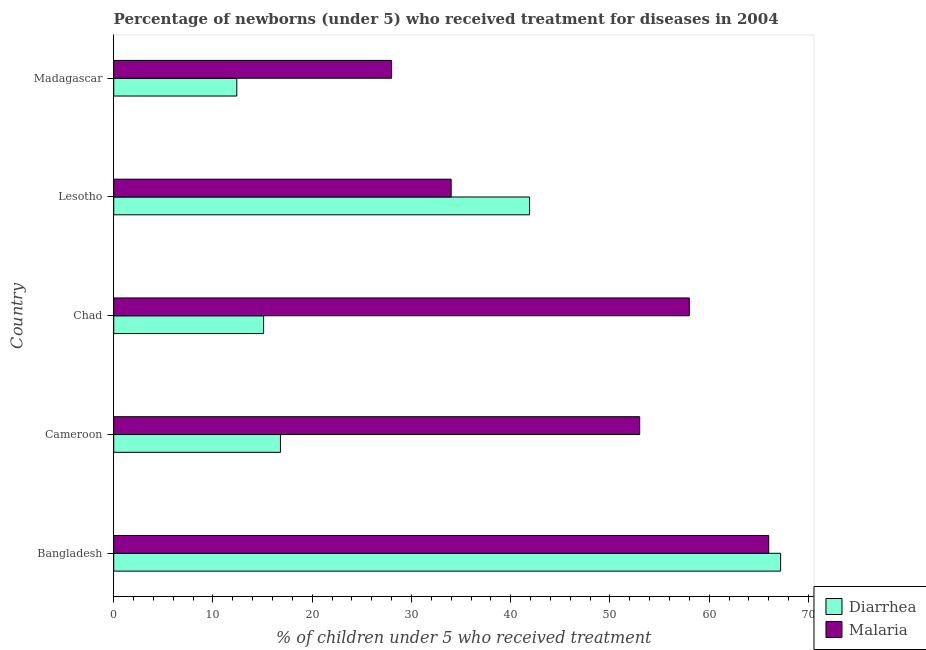How many different coloured bars are there?
Provide a short and direct response. 2. How many groups of bars are there?
Offer a very short reply. 5. How many bars are there on the 5th tick from the top?
Keep it short and to the point. 2. How many bars are there on the 1st tick from the bottom?
Offer a terse response. 2. What is the label of the 1st group of bars from the top?
Offer a terse response. Madagascar. What is the percentage of children who received treatment for malaria in Madagascar?
Make the answer very short. 28. Across all countries, what is the maximum percentage of children who received treatment for diarrhoea?
Ensure brevity in your answer.  67.2. Across all countries, what is the minimum percentage of children who received treatment for diarrhoea?
Provide a short and direct response. 12.4. In which country was the percentage of children who received treatment for malaria minimum?
Ensure brevity in your answer.  Madagascar. What is the total percentage of children who received treatment for diarrhoea in the graph?
Offer a terse response. 153.4. What is the difference between the percentage of children who received treatment for diarrhoea in Lesotho and that in Madagascar?
Your answer should be compact. 29.5. What is the difference between the percentage of children who received treatment for diarrhoea in Bangladesh and the percentage of children who received treatment for malaria in Madagascar?
Your answer should be compact. 39.2. What is the average percentage of children who received treatment for malaria per country?
Offer a very short reply. 47.8. What is the difference between the percentage of children who received treatment for diarrhoea and percentage of children who received treatment for malaria in Chad?
Your answer should be compact. -42.9. In how many countries, is the percentage of children who received treatment for malaria greater than 54 %?
Your answer should be compact. 2. What is the ratio of the percentage of children who received treatment for malaria in Bangladesh to that in Cameroon?
Give a very brief answer. 1.25. Is the percentage of children who received treatment for diarrhoea in Bangladesh less than that in Lesotho?
Your answer should be very brief. No. Is the difference between the percentage of children who received treatment for diarrhoea in Cameroon and Chad greater than the difference between the percentage of children who received treatment for malaria in Cameroon and Chad?
Your answer should be very brief. Yes. What is the difference between the highest and the second highest percentage of children who received treatment for malaria?
Make the answer very short. 8. What is the difference between the highest and the lowest percentage of children who received treatment for malaria?
Keep it short and to the point. 38. What does the 1st bar from the top in Bangladesh represents?
Offer a terse response. Malaria. What does the 1st bar from the bottom in Lesotho represents?
Provide a succinct answer. Diarrhea. Are the values on the major ticks of X-axis written in scientific E-notation?
Your answer should be very brief. No. Does the graph contain any zero values?
Your answer should be compact. No. How many legend labels are there?
Ensure brevity in your answer.  2. How are the legend labels stacked?
Provide a short and direct response. Vertical. What is the title of the graph?
Make the answer very short. Percentage of newborns (under 5) who received treatment for diseases in 2004. What is the label or title of the X-axis?
Offer a terse response. % of children under 5 who received treatment. What is the % of children under 5 who received treatment in Diarrhea in Bangladesh?
Make the answer very short. 67.2. What is the % of children under 5 who received treatment of Malaria in Bangladesh?
Make the answer very short. 66. What is the % of children under 5 who received treatment in Diarrhea in Cameroon?
Ensure brevity in your answer.  16.8. What is the % of children under 5 who received treatment of Malaria in Cameroon?
Give a very brief answer. 53. What is the % of children under 5 who received treatment in Diarrhea in Chad?
Provide a succinct answer. 15.1. What is the % of children under 5 who received treatment in Diarrhea in Lesotho?
Provide a succinct answer. 41.9. What is the % of children under 5 who received treatment of Malaria in Lesotho?
Offer a very short reply. 34. What is the % of children under 5 who received treatment of Malaria in Madagascar?
Your response must be concise. 28. Across all countries, what is the maximum % of children under 5 who received treatment in Diarrhea?
Keep it short and to the point. 67.2. Across all countries, what is the maximum % of children under 5 who received treatment of Malaria?
Keep it short and to the point. 66. Across all countries, what is the minimum % of children under 5 who received treatment of Diarrhea?
Ensure brevity in your answer.  12.4. What is the total % of children under 5 who received treatment of Diarrhea in the graph?
Provide a succinct answer. 153.4. What is the total % of children under 5 who received treatment in Malaria in the graph?
Make the answer very short. 239. What is the difference between the % of children under 5 who received treatment in Diarrhea in Bangladesh and that in Cameroon?
Provide a short and direct response. 50.4. What is the difference between the % of children under 5 who received treatment of Diarrhea in Bangladesh and that in Chad?
Offer a very short reply. 52.1. What is the difference between the % of children under 5 who received treatment of Malaria in Bangladesh and that in Chad?
Give a very brief answer. 8. What is the difference between the % of children under 5 who received treatment in Diarrhea in Bangladesh and that in Lesotho?
Your answer should be compact. 25.3. What is the difference between the % of children under 5 who received treatment of Diarrhea in Bangladesh and that in Madagascar?
Your answer should be compact. 54.8. What is the difference between the % of children under 5 who received treatment of Malaria in Bangladesh and that in Madagascar?
Provide a short and direct response. 38. What is the difference between the % of children under 5 who received treatment of Malaria in Cameroon and that in Chad?
Your answer should be compact. -5. What is the difference between the % of children under 5 who received treatment in Diarrhea in Cameroon and that in Lesotho?
Offer a very short reply. -25.1. What is the difference between the % of children under 5 who received treatment in Diarrhea in Chad and that in Lesotho?
Your answer should be compact. -26.8. What is the difference between the % of children under 5 who received treatment of Malaria in Chad and that in Lesotho?
Keep it short and to the point. 24. What is the difference between the % of children under 5 who received treatment in Diarrhea in Lesotho and that in Madagascar?
Keep it short and to the point. 29.5. What is the difference between the % of children under 5 who received treatment of Diarrhea in Bangladesh and the % of children under 5 who received treatment of Malaria in Cameroon?
Your response must be concise. 14.2. What is the difference between the % of children under 5 who received treatment of Diarrhea in Bangladesh and the % of children under 5 who received treatment of Malaria in Chad?
Offer a very short reply. 9.2. What is the difference between the % of children under 5 who received treatment in Diarrhea in Bangladesh and the % of children under 5 who received treatment in Malaria in Lesotho?
Your answer should be very brief. 33.2. What is the difference between the % of children under 5 who received treatment of Diarrhea in Bangladesh and the % of children under 5 who received treatment of Malaria in Madagascar?
Keep it short and to the point. 39.2. What is the difference between the % of children under 5 who received treatment of Diarrhea in Cameroon and the % of children under 5 who received treatment of Malaria in Chad?
Keep it short and to the point. -41.2. What is the difference between the % of children under 5 who received treatment in Diarrhea in Cameroon and the % of children under 5 who received treatment in Malaria in Lesotho?
Give a very brief answer. -17.2. What is the difference between the % of children under 5 who received treatment in Diarrhea in Cameroon and the % of children under 5 who received treatment in Malaria in Madagascar?
Your answer should be very brief. -11.2. What is the difference between the % of children under 5 who received treatment of Diarrhea in Chad and the % of children under 5 who received treatment of Malaria in Lesotho?
Make the answer very short. -18.9. What is the difference between the % of children under 5 who received treatment in Diarrhea in Lesotho and the % of children under 5 who received treatment in Malaria in Madagascar?
Your answer should be very brief. 13.9. What is the average % of children under 5 who received treatment of Diarrhea per country?
Your response must be concise. 30.68. What is the average % of children under 5 who received treatment of Malaria per country?
Keep it short and to the point. 47.8. What is the difference between the % of children under 5 who received treatment in Diarrhea and % of children under 5 who received treatment in Malaria in Cameroon?
Ensure brevity in your answer.  -36.2. What is the difference between the % of children under 5 who received treatment of Diarrhea and % of children under 5 who received treatment of Malaria in Chad?
Your response must be concise. -42.9. What is the difference between the % of children under 5 who received treatment of Diarrhea and % of children under 5 who received treatment of Malaria in Madagascar?
Your answer should be compact. -15.6. What is the ratio of the % of children under 5 who received treatment of Malaria in Bangladesh to that in Cameroon?
Provide a succinct answer. 1.25. What is the ratio of the % of children under 5 who received treatment in Diarrhea in Bangladesh to that in Chad?
Give a very brief answer. 4.45. What is the ratio of the % of children under 5 who received treatment of Malaria in Bangladesh to that in Chad?
Provide a succinct answer. 1.14. What is the ratio of the % of children under 5 who received treatment in Diarrhea in Bangladesh to that in Lesotho?
Make the answer very short. 1.6. What is the ratio of the % of children under 5 who received treatment in Malaria in Bangladesh to that in Lesotho?
Your answer should be compact. 1.94. What is the ratio of the % of children under 5 who received treatment of Diarrhea in Bangladesh to that in Madagascar?
Your answer should be compact. 5.42. What is the ratio of the % of children under 5 who received treatment of Malaria in Bangladesh to that in Madagascar?
Provide a succinct answer. 2.36. What is the ratio of the % of children under 5 who received treatment in Diarrhea in Cameroon to that in Chad?
Provide a succinct answer. 1.11. What is the ratio of the % of children under 5 who received treatment in Malaria in Cameroon to that in Chad?
Offer a terse response. 0.91. What is the ratio of the % of children under 5 who received treatment in Diarrhea in Cameroon to that in Lesotho?
Provide a succinct answer. 0.4. What is the ratio of the % of children under 5 who received treatment of Malaria in Cameroon to that in Lesotho?
Provide a short and direct response. 1.56. What is the ratio of the % of children under 5 who received treatment of Diarrhea in Cameroon to that in Madagascar?
Your answer should be compact. 1.35. What is the ratio of the % of children under 5 who received treatment in Malaria in Cameroon to that in Madagascar?
Your response must be concise. 1.89. What is the ratio of the % of children under 5 who received treatment in Diarrhea in Chad to that in Lesotho?
Your answer should be very brief. 0.36. What is the ratio of the % of children under 5 who received treatment in Malaria in Chad to that in Lesotho?
Ensure brevity in your answer.  1.71. What is the ratio of the % of children under 5 who received treatment in Diarrhea in Chad to that in Madagascar?
Give a very brief answer. 1.22. What is the ratio of the % of children under 5 who received treatment in Malaria in Chad to that in Madagascar?
Offer a terse response. 2.07. What is the ratio of the % of children under 5 who received treatment of Diarrhea in Lesotho to that in Madagascar?
Your answer should be compact. 3.38. What is the ratio of the % of children under 5 who received treatment in Malaria in Lesotho to that in Madagascar?
Give a very brief answer. 1.21. What is the difference between the highest and the second highest % of children under 5 who received treatment of Diarrhea?
Offer a very short reply. 25.3. What is the difference between the highest and the second highest % of children under 5 who received treatment in Malaria?
Your answer should be very brief. 8. What is the difference between the highest and the lowest % of children under 5 who received treatment of Diarrhea?
Make the answer very short. 54.8. 